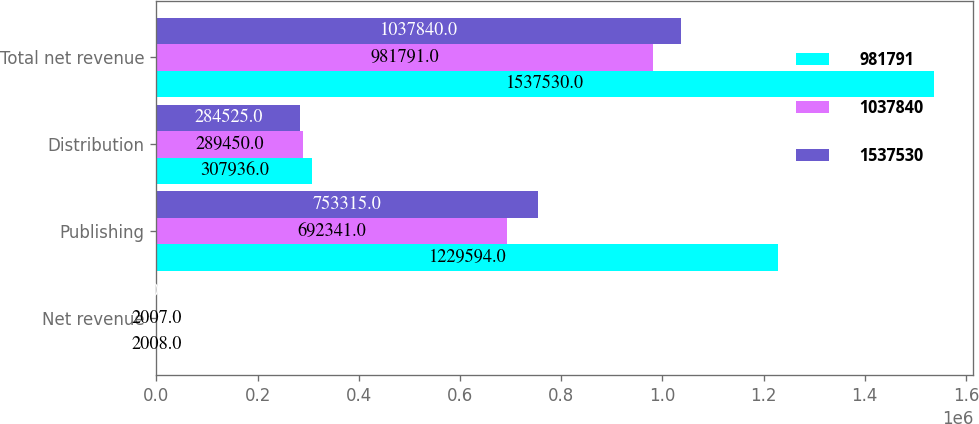<chart> <loc_0><loc_0><loc_500><loc_500><stacked_bar_chart><ecel><fcel>Net revenue<fcel>Publishing<fcel>Distribution<fcel>Total net revenue<nl><fcel>981791<fcel>2008<fcel>1.22959e+06<fcel>307936<fcel>1.53753e+06<nl><fcel>1.03784e+06<fcel>2007<fcel>692341<fcel>289450<fcel>981791<nl><fcel>1.53753e+06<fcel>2006<fcel>753315<fcel>284525<fcel>1.03784e+06<nl></chart> 